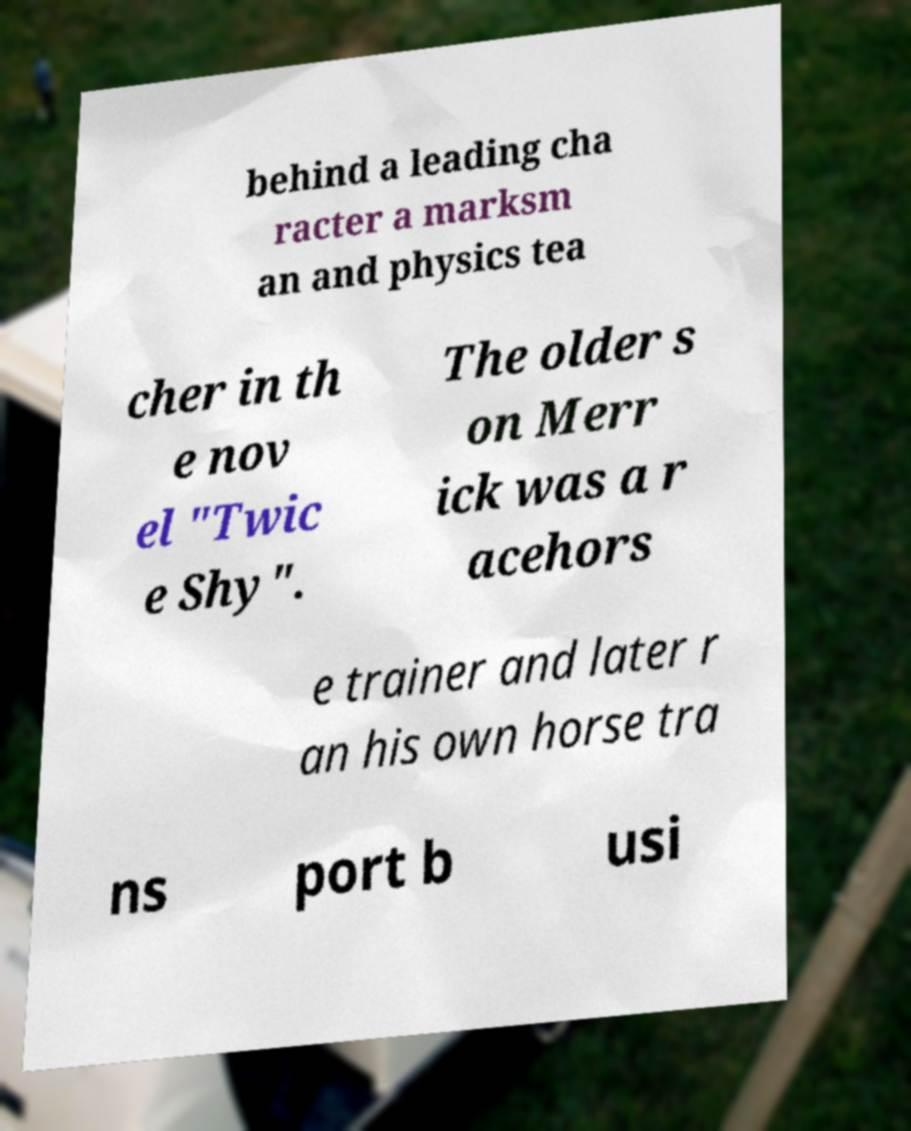I need the written content from this picture converted into text. Can you do that? behind a leading cha racter a marksm an and physics tea cher in th e nov el "Twic e Shy". The older s on Merr ick was a r acehors e trainer and later r an his own horse tra ns port b usi 